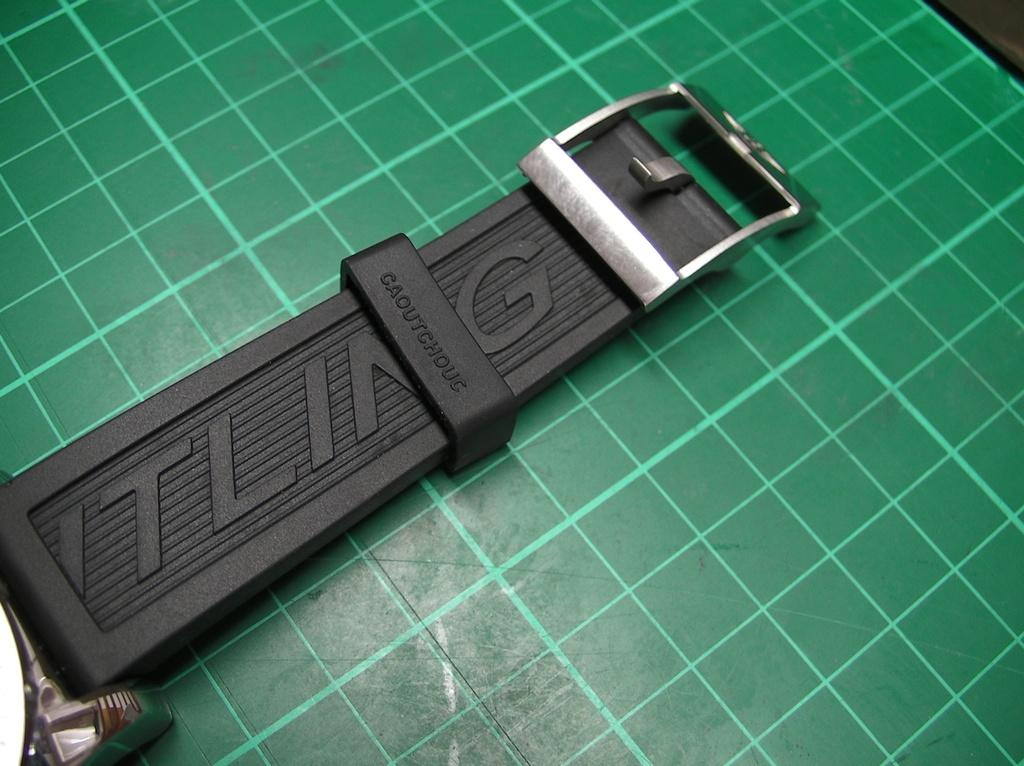Provide a one-sentence caption for the provided image. An ITLING buckle laying on a background that is green. 